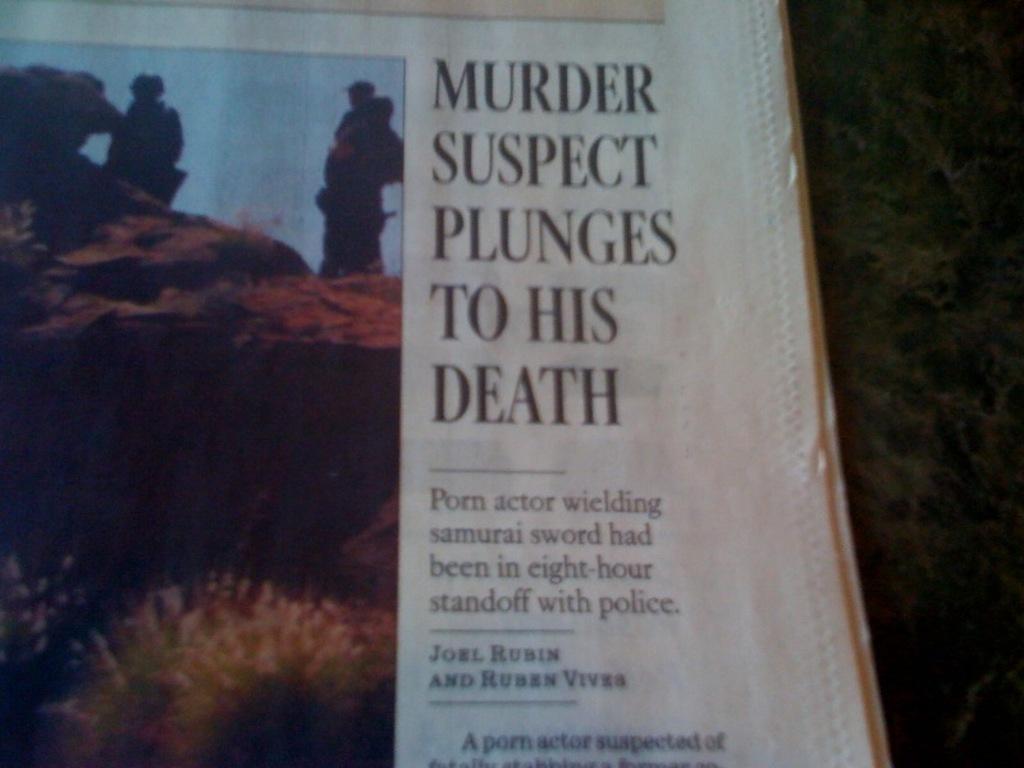What does it say under the headline?
Provide a short and direct response. Porn actor wielding samurai sword. 